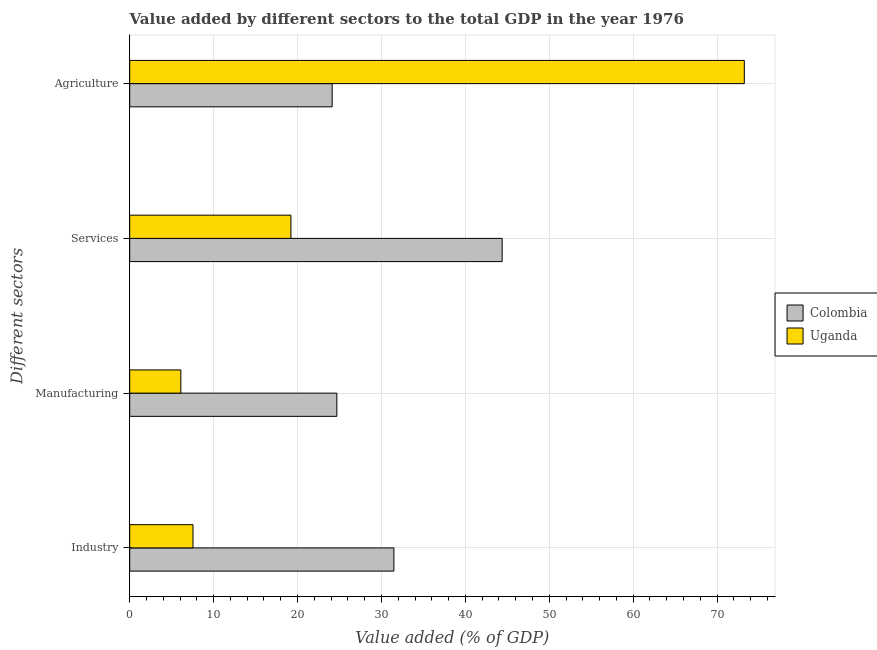How many groups of bars are there?
Offer a very short reply. 4. Are the number of bars on each tick of the Y-axis equal?
Offer a terse response. Yes. How many bars are there on the 3rd tick from the bottom?
Keep it short and to the point. 2. What is the label of the 3rd group of bars from the top?
Ensure brevity in your answer.  Manufacturing. What is the value added by industrial sector in Uganda?
Your response must be concise. 7.54. Across all countries, what is the maximum value added by industrial sector?
Provide a succinct answer. 31.48. Across all countries, what is the minimum value added by agricultural sector?
Give a very brief answer. 24.13. In which country was the value added by industrial sector maximum?
Your response must be concise. Colombia. What is the total value added by industrial sector in the graph?
Offer a terse response. 39.03. What is the difference between the value added by manufacturing sector in Colombia and that in Uganda?
Provide a succinct answer. 18.59. What is the difference between the value added by manufacturing sector in Uganda and the value added by industrial sector in Colombia?
Give a very brief answer. -25.39. What is the average value added by agricultural sector per country?
Offer a very short reply. 48.69. What is the difference between the value added by services sector and value added by agricultural sector in Colombia?
Your response must be concise. 20.26. In how many countries, is the value added by manufacturing sector greater than 28 %?
Offer a very short reply. 0. What is the ratio of the value added by industrial sector in Uganda to that in Colombia?
Your answer should be very brief. 0.24. Is the value added by services sector in Uganda less than that in Colombia?
Your answer should be compact. Yes. Is the difference between the value added by agricultural sector in Uganda and Colombia greater than the difference between the value added by manufacturing sector in Uganda and Colombia?
Offer a terse response. Yes. What is the difference between the highest and the second highest value added by services sector?
Provide a succinct answer. 25.18. What is the difference between the highest and the lowest value added by manufacturing sector?
Provide a short and direct response. 18.59. In how many countries, is the value added by agricultural sector greater than the average value added by agricultural sector taken over all countries?
Your answer should be very brief. 1. Is the sum of the value added by services sector in Uganda and Colombia greater than the maximum value added by industrial sector across all countries?
Your response must be concise. Yes. What does the 2nd bar from the top in Services represents?
Ensure brevity in your answer.  Colombia. Is it the case that in every country, the sum of the value added by industrial sector and value added by manufacturing sector is greater than the value added by services sector?
Provide a short and direct response. No. How many bars are there?
Make the answer very short. 8. How many countries are there in the graph?
Give a very brief answer. 2. Are the values on the major ticks of X-axis written in scientific E-notation?
Give a very brief answer. No. Does the graph contain any zero values?
Ensure brevity in your answer.  No. Where does the legend appear in the graph?
Ensure brevity in your answer.  Center right. How many legend labels are there?
Ensure brevity in your answer.  2. What is the title of the graph?
Ensure brevity in your answer.  Value added by different sectors to the total GDP in the year 1976. Does "Netherlands" appear as one of the legend labels in the graph?
Your answer should be very brief. No. What is the label or title of the X-axis?
Make the answer very short. Value added (% of GDP). What is the label or title of the Y-axis?
Give a very brief answer. Different sectors. What is the Value added (% of GDP) in Colombia in Industry?
Offer a terse response. 31.48. What is the Value added (% of GDP) of Uganda in Industry?
Ensure brevity in your answer.  7.54. What is the Value added (% of GDP) in Colombia in Manufacturing?
Give a very brief answer. 24.69. What is the Value added (% of GDP) of Uganda in Manufacturing?
Ensure brevity in your answer.  6.09. What is the Value added (% of GDP) of Colombia in Services?
Your response must be concise. 44.39. What is the Value added (% of GDP) in Uganda in Services?
Give a very brief answer. 19.21. What is the Value added (% of GDP) of Colombia in Agriculture?
Offer a terse response. 24.13. What is the Value added (% of GDP) in Uganda in Agriculture?
Offer a terse response. 73.25. Across all Different sectors, what is the maximum Value added (% of GDP) in Colombia?
Make the answer very short. 44.39. Across all Different sectors, what is the maximum Value added (% of GDP) of Uganda?
Make the answer very short. 73.25. Across all Different sectors, what is the minimum Value added (% of GDP) of Colombia?
Offer a very short reply. 24.13. Across all Different sectors, what is the minimum Value added (% of GDP) in Uganda?
Your response must be concise. 6.09. What is the total Value added (% of GDP) of Colombia in the graph?
Provide a short and direct response. 124.69. What is the total Value added (% of GDP) in Uganda in the graph?
Offer a very short reply. 106.09. What is the difference between the Value added (% of GDP) of Colombia in Industry and that in Manufacturing?
Provide a succinct answer. 6.8. What is the difference between the Value added (% of GDP) in Uganda in Industry and that in Manufacturing?
Provide a short and direct response. 1.45. What is the difference between the Value added (% of GDP) of Colombia in Industry and that in Services?
Offer a terse response. -12.9. What is the difference between the Value added (% of GDP) in Uganda in Industry and that in Services?
Provide a short and direct response. -11.67. What is the difference between the Value added (% of GDP) of Colombia in Industry and that in Agriculture?
Offer a terse response. 7.36. What is the difference between the Value added (% of GDP) in Uganda in Industry and that in Agriculture?
Your answer should be compact. -65.71. What is the difference between the Value added (% of GDP) in Colombia in Manufacturing and that in Services?
Give a very brief answer. -19.7. What is the difference between the Value added (% of GDP) of Uganda in Manufacturing and that in Services?
Provide a short and direct response. -13.12. What is the difference between the Value added (% of GDP) of Colombia in Manufacturing and that in Agriculture?
Ensure brevity in your answer.  0.56. What is the difference between the Value added (% of GDP) of Uganda in Manufacturing and that in Agriculture?
Provide a short and direct response. -67.16. What is the difference between the Value added (% of GDP) in Colombia in Services and that in Agriculture?
Your response must be concise. 20.26. What is the difference between the Value added (% of GDP) of Uganda in Services and that in Agriculture?
Make the answer very short. -54.04. What is the difference between the Value added (% of GDP) in Colombia in Industry and the Value added (% of GDP) in Uganda in Manufacturing?
Your answer should be compact. 25.39. What is the difference between the Value added (% of GDP) of Colombia in Industry and the Value added (% of GDP) of Uganda in Services?
Ensure brevity in your answer.  12.27. What is the difference between the Value added (% of GDP) of Colombia in Industry and the Value added (% of GDP) of Uganda in Agriculture?
Offer a terse response. -41.76. What is the difference between the Value added (% of GDP) of Colombia in Manufacturing and the Value added (% of GDP) of Uganda in Services?
Make the answer very short. 5.48. What is the difference between the Value added (% of GDP) in Colombia in Manufacturing and the Value added (% of GDP) in Uganda in Agriculture?
Provide a short and direct response. -48.56. What is the difference between the Value added (% of GDP) of Colombia in Services and the Value added (% of GDP) of Uganda in Agriculture?
Provide a succinct answer. -28.86. What is the average Value added (% of GDP) in Colombia per Different sectors?
Offer a terse response. 31.17. What is the average Value added (% of GDP) in Uganda per Different sectors?
Provide a succinct answer. 26.52. What is the difference between the Value added (% of GDP) of Colombia and Value added (% of GDP) of Uganda in Industry?
Keep it short and to the point. 23.94. What is the difference between the Value added (% of GDP) in Colombia and Value added (% of GDP) in Uganda in Manufacturing?
Offer a very short reply. 18.59. What is the difference between the Value added (% of GDP) in Colombia and Value added (% of GDP) in Uganda in Services?
Give a very brief answer. 25.18. What is the difference between the Value added (% of GDP) of Colombia and Value added (% of GDP) of Uganda in Agriculture?
Keep it short and to the point. -49.12. What is the ratio of the Value added (% of GDP) of Colombia in Industry to that in Manufacturing?
Your answer should be compact. 1.28. What is the ratio of the Value added (% of GDP) in Uganda in Industry to that in Manufacturing?
Your answer should be compact. 1.24. What is the ratio of the Value added (% of GDP) of Colombia in Industry to that in Services?
Ensure brevity in your answer.  0.71. What is the ratio of the Value added (% of GDP) in Uganda in Industry to that in Services?
Provide a short and direct response. 0.39. What is the ratio of the Value added (% of GDP) in Colombia in Industry to that in Agriculture?
Your answer should be compact. 1.3. What is the ratio of the Value added (% of GDP) in Uganda in Industry to that in Agriculture?
Offer a very short reply. 0.1. What is the ratio of the Value added (% of GDP) of Colombia in Manufacturing to that in Services?
Provide a short and direct response. 0.56. What is the ratio of the Value added (% of GDP) of Uganda in Manufacturing to that in Services?
Offer a terse response. 0.32. What is the ratio of the Value added (% of GDP) in Colombia in Manufacturing to that in Agriculture?
Keep it short and to the point. 1.02. What is the ratio of the Value added (% of GDP) of Uganda in Manufacturing to that in Agriculture?
Keep it short and to the point. 0.08. What is the ratio of the Value added (% of GDP) in Colombia in Services to that in Agriculture?
Your answer should be compact. 1.84. What is the ratio of the Value added (% of GDP) of Uganda in Services to that in Agriculture?
Give a very brief answer. 0.26. What is the difference between the highest and the second highest Value added (% of GDP) in Colombia?
Keep it short and to the point. 12.9. What is the difference between the highest and the second highest Value added (% of GDP) in Uganda?
Your response must be concise. 54.04. What is the difference between the highest and the lowest Value added (% of GDP) in Colombia?
Offer a terse response. 20.26. What is the difference between the highest and the lowest Value added (% of GDP) of Uganda?
Your answer should be very brief. 67.16. 